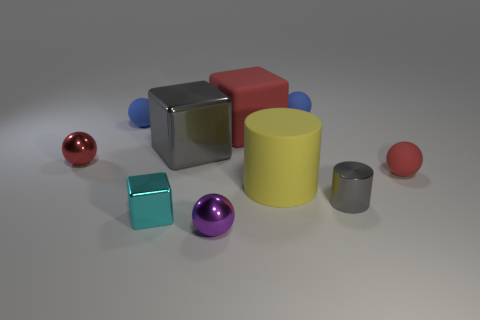Is the number of small metal balls less than the number of small purple balls? Upon closer inspection of the image, the number of small metal balls appears to be equal to the number of small purple balls, with each category having two balls. 